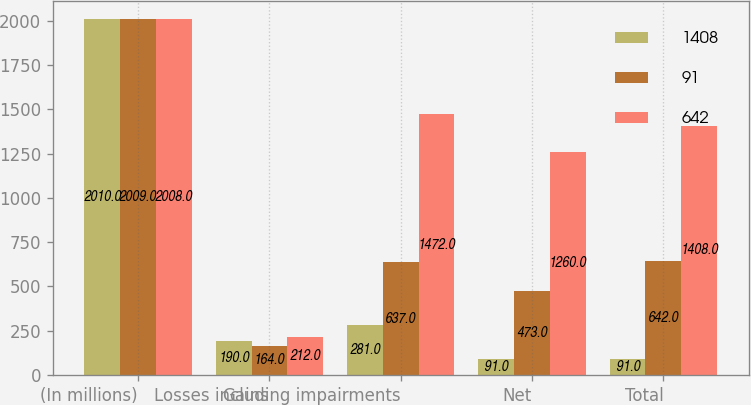<chart> <loc_0><loc_0><loc_500><loc_500><stacked_bar_chart><ecel><fcel>(In millions)<fcel>Gains<fcel>Losses including impairments<fcel>Net<fcel>Total<nl><fcel>1408<fcel>2010<fcel>190<fcel>281<fcel>91<fcel>91<nl><fcel>91<fcel>2009<fcel>164<fcel>637<fcel>473<fcel>642<nl><fcel>642<fcel>2008<fcel>212<fcel>1472<fcel>1260<fcel>1408<nl></chart> 